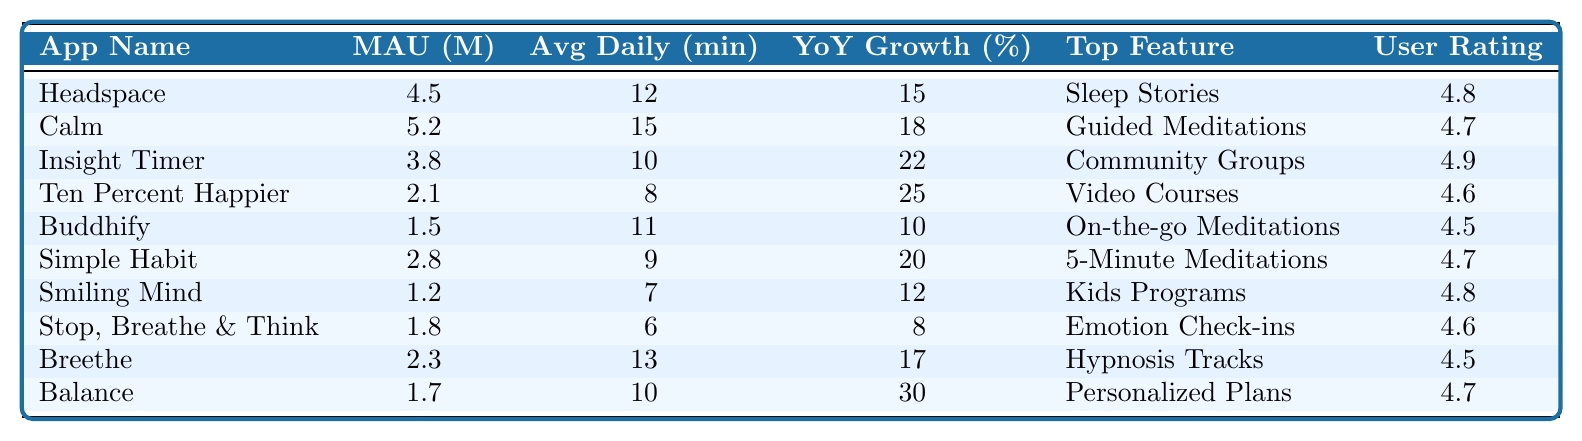What is the app with the highest number of monthly active users? Looking at the "Monthly Active Users (millions)" column, Calm has the highest value at 5.2 million.
Answer: Calm Which app has the lowest user rating? By examining the "User Rating" column, Buddhify has the lowest rating of 4.5.
Answer: Buddhify What is the average daily usage of Insight Timer? The average daily usage for Insight Timer, as shown in the "Average Daily Usage (minutes)" column, is 10 minutes.
Answer: 10 minutes What is the year-over-year growth percentage for Ten Percent Happier? The "Year-over-Year Growth (%)" column shows that Ten Percent Happier has a growth of 25%.
Answer: 25% Which app has the top feature of "Guided Meditations"? The app listed under "Top Feature" as "Guided Meditations" is Calm.
Answer: Calm How many apps have a user rating of 4.8 or higher? The apps with a rating of 4.8 or higher are Headspace, Insight Timer, and Smiling Mind, totaling three apps.
Answer: 3 apps What is the difference in monthly active users between Calm and Headspace? Calm has 5.2 million users, and Headspace has 4.5 million users. The difference is 5.2 - 4.5 = 0.7 million.
Answer: 0.7 million Average the daily usage time of all apps listed. Summing the daily usage: 12 + 15 + 10 + 8 + 11 + 9 + 7 + 6 + 13 + 10 = 91 minutes; there are 10 apps, so the average is 91 / 10 = 9.1 minutes.
Answer: 9.1 minutes Is it true that Breethe has a higher user rating than Balance? Breethe has a user rating of 4.5, while Balance has a rating of 4.7. Therefore, this statement is false.
Answer: No Which app has the highest year-over-year growth and what is that percentage? Ten Percent Happier shows the highest growth of 25% in the "Year-over-Year Growth (%)" column.
Answer: 25% 